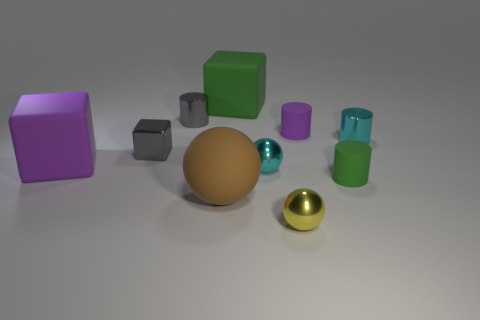Is there a blue shiny cube? Upon reviewing the image, I can confirm that there is no blue shiny cube present. The objects depicted include a variety of geometric shapes with different colors and finishes, such as a green cube, grey cubes, a purple cube, round spheres, and cylinders, but a blue shiny cube is not among them. 